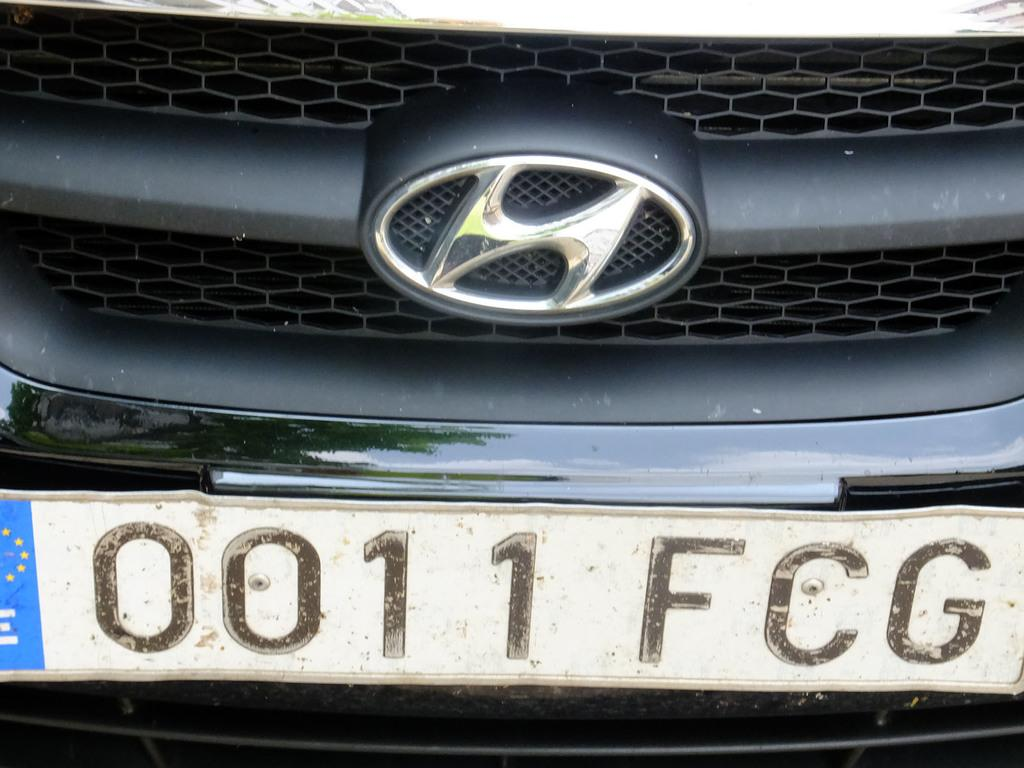<image>
Render a clear and concise summary of the photo. A black car has the numbers 0011 below the grill. 